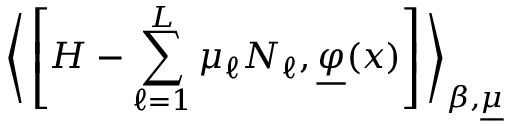Convert formula to latex. <formula><loc_0><loc_0><loc_500><loc_500>\left \langle \left [ H - \sum _ { \ell = 1 } ^ { L } \mu _ { \ell } N _ { \ell } , \underline { \varphi } ( x ) \right ] \right \rangle _ { \beta , \underline { \mu } }</formula> 